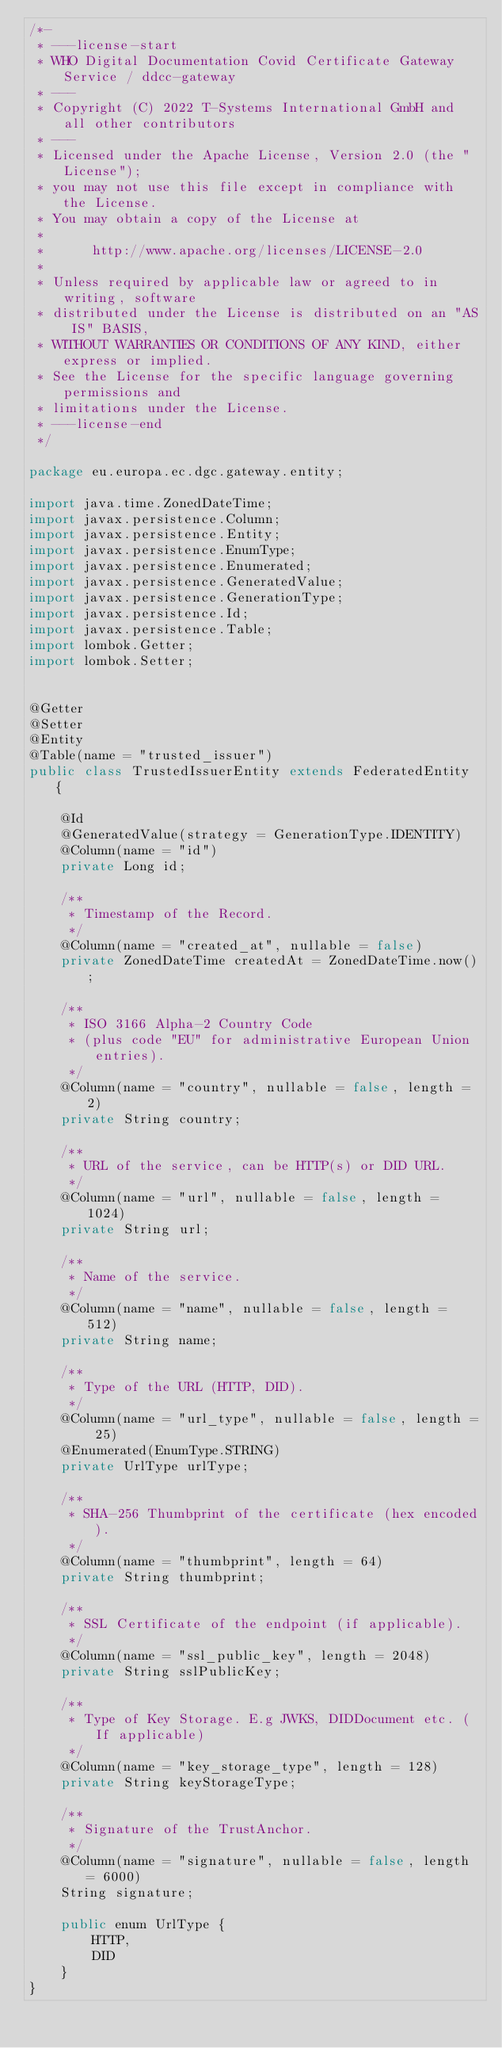<code> <loc_0><loc_0><loc_500><loc_500><_Java_>/*-
 * ---license-start
 * WHO Digital Documentation Covid Certificate Gateway Service / ddcc-gateway
 * ---
 * Copyright (C) 2022 T-Systems International GmbH and all other contributors
 * ---
 * Licensed under the Apache License, Version 2.0 (the "License");
 * you may not use this file except in compliance with the License.
 * You may obtain a copy of the License at
 *
 *      http://www.apache.org/licenses/LICENSE-2.0
 *
 * Unless required by applicable law or agreed to in writing, software
 * distributed under the License is distributed on an "AS IS" BASIS,
 * WITHOUT WARRANTIES OR CONDITIONS OF ANY KIND, either express or implied.
 * See the License for the specific language governing permissions and
 * limitations under the License.
 * ---license-end
 */

package eu.europa.ec.dgc.gateway.entity;

import java.time.ZonedDateTime;
import javax.persistence.Column;
import javax.persistence.Entity;
import javax.persistence.EnumType;
import javax.persistence.Enumerated;
import javax.persistence.GeneratedValue;
import javax.persistence.GenerationType;
import javax.persistence.Id;
import javax.persistence.Table;
import lombok.Getter;
import lombok.Setter;


@Getter
@Setter
@Entity
@Table(name = "trusted_issuer")
public class TrustedIssuerEntity extends FederatedEntity {

    @Id
    @GeneratedValue(strategy = GenerationType.IDENTITY)
    @Column(name = "id")
    private Long id;

    /**
     * Timestamp of the Record.
     */
    @Column(name = "created_at", nullable = false)
    private ZonedDateTime createdAt = ZonedDateTime.now();

    /**
     * ISO 3166 Alpha-2 Country Code
     * (plus code "EU" for administrative European Union entries).
     */
    @Column(name = "country", nullable = false, length = 2)
    private String country;

    /**
     * URL of the service, can be HTTP(s) or DID URL.
     */
    @Column(name = "url", nullable = false, length = 1024)
    private String url;

    /**
     * Name of the service.
     */
    @Column(name = "name", nullable = false, length = 512)
    private String name;

    /**
     * Type of the URL (HTTP, DID).
     */
    @Column(name = "url_type", nullable = false, length = 25)
    @Enumerated(EnumType.STRING)
    private UrlType urlType;

    /**
     * SHA-256 Thumbprint of the certificate (hex encoded).
     */
    @Column(name = "thumbprint", length = 64)
    private String thumbprint;

    /**
     * SSL Certificate of the endpoint (if applicable).
     */
    @Column(name = "ssl_public_key", length = 2048)
    private String sslPublicKey;

    /**
     * Type of Key Storage. E.g JWKS, DIDDocument etc. (If applicable)
     */
    @Column(name = "key_storage_type", length = 128)
    private String keyStorageType;

    /**
     * Signature of the TrustAnchor.
     */
    @Column(name = "signature", nullable = false, length = 6000)
    String signature;

    public enum UrlType {
        HTTP,
        DID
    }
}
</code> 